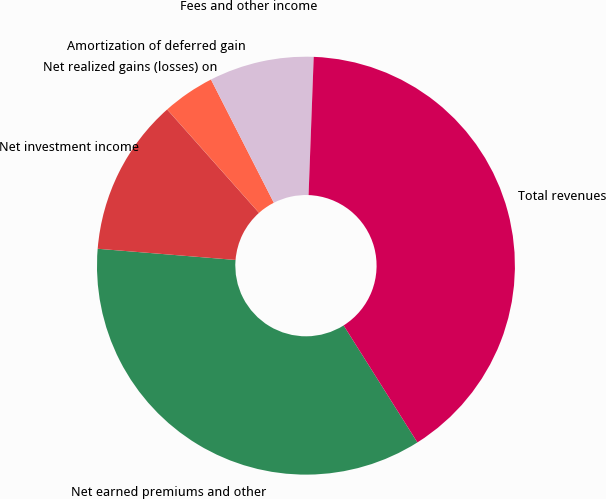Convert chart. <chart><loc_0><loc_0><loc_500><loc_500><pie_chart><fcel>Net earned premiums and other<fcel>Net investment income<fcel>Net realized gains (losses) on<fcel>Amortization of deferred gain<fcel>Fees and other income<fcel>Total revenues<nl><fcel>35.24%<fcel>12.14%<fcel>0.01%<fcel>4.05%<fcel>8.1%<fcel>40.45%<nl></chart> 